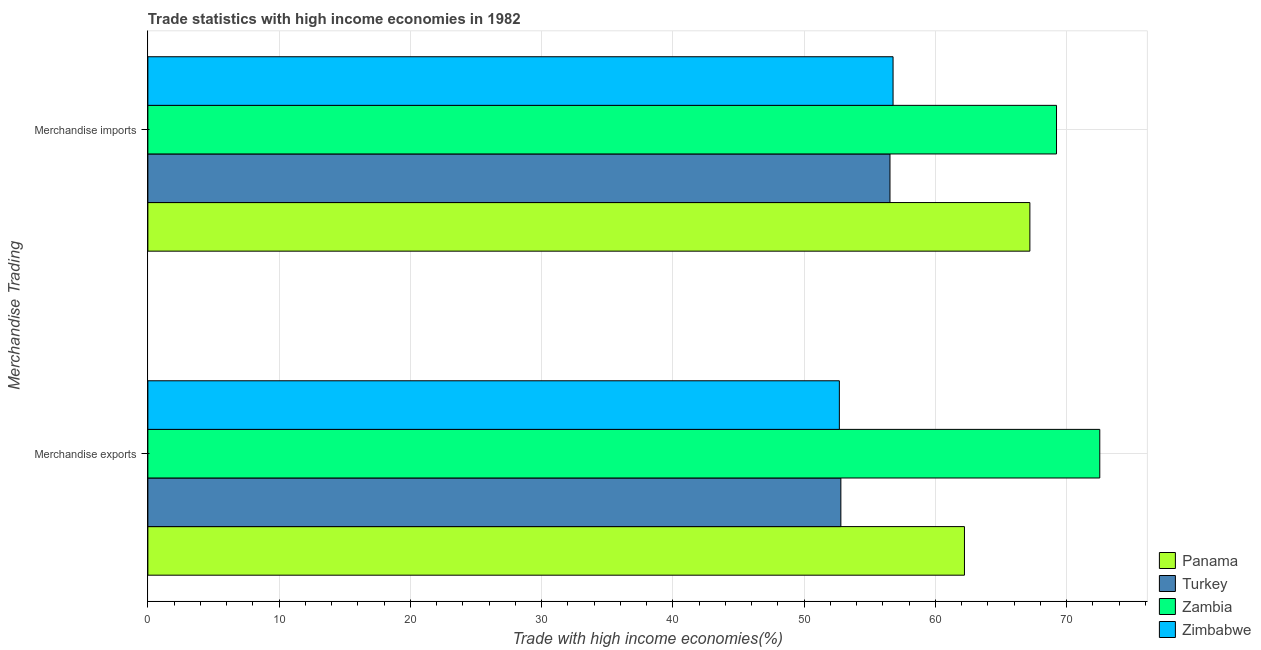Are the number of bars on each tick of the Y-axis equal?
Ensure brevity in your answer.  Yes. What is the merchandise imports in Panama?
Your answer should be very brief. 67.2. Across all countries, what is the maximum merchandise exports?
Offer a terse response. 72.52. Across all countries, what is the minimum merchandise imports?
Provide a short and direct response. 56.54. In which country was the merchandise imports maximum?
Your answer should be compact. Zambia. In which country was the merchandise exports minimum?
Your answer should be very brief. Zimbabwe. What is the total merchandise imports in the graph?
Your answer should be very brief. 249.73. What is the difference between the merchandise imports in Panama and that in Turkey?
Ensure brevity in your answer.  10.66. What is the difference between the merchandise exports in Zimbabwe and the merchandise imports in Zambia?
Keep it short and to the point. -16.54. What is the average merchandise exports per country?
Ensure brevity in your answer.  60.05. What is the difference between the merchandise exports and merchandise imports in Zimbabwe?
Your answer should be compact. -4.09. What is the ratio of the merchandise exports in Zambia to that in Panama?
Your answer should be compact. 1.17. In how many countries, is the merchandise exports greater than the average merchandise exports taken over all countries?
Keep it short and to the point. 2. What does the 1st bar from the top in Merchandise imports represents?
Your answer should be very brief. Zimbabwe. What does the 1st bar from the bottom in Merchandise exports represents?
Provide a short and direct response. Panama. How many bars are there?
Give a very brief answer. 8. Are all the bars in the graph horizontal?
Offer a very short reply. Yes. How many countries are there in the graph?
Offer a very short reply. 4. What is the difference between two consecutive major ticks on the X-axis?
Give a very brief answer. 10. How many legend labels are there?
Offer a very short reply. 4. How are the legend labels stacked?
Provide a short and direct response. Vertical. What is the title of the graph?
Offer a very short reply. Trade statistics with high income economies in 1982. Does "Saudi Arabia" appear as one of the legend labels in the graph?
Offer a very short reply. No. What is the label or title of the X-axis?
Provide a succinct answer. Trade with high income economies(%). What is the label or title of the Y-axis?
Offer a very short reply. Merchandise Trading. What is the Trade with high income economies(%) of Panama in Merchandise exports?
Ensure brevity in your answer.  62.21. What is the Trade with high income economies(%) in Turkey in Merchandise exports?
Ensure brevity in your answer.  52.8. What is the Trade with high income economies(%) of Zambia in Merchandise exports?
Offer a very short reply. 72.52. What is the Trade with high income economies(%) in Zimbabwe in Merchandise exports?
Provide a short and direct response. 52.68. What is the Trade with high income economies(%) in Panama in Merchandise imports?
Give a very brief answer. 67.2. What is the Trade with high income economies(%) of Turkey in Merchandise imports?
Make the answer very short. 56.54. What is the Trade with high income economies(%) of Zambia in Merchandise imports?
Your response must be concise. 69.23. What is the Trade with high income economies(%) in Zimbabwe in Merchandise imports?
Your answer should be compact. 56.77. Across all Merchandise Trading, what is the maximum Trade with high income economies(%) in Panama?
Provide a short and direct response. 67.2. Across all Merchandise Trading, what is the maximum Trade with high income economies(%) in Turkey?
Provide a succinct answer. 56.54. Across all Merchandise Trading, what is the maximum Trade with high income economies(%) of Zambia?
Offer a terse response. 72.52. Across all Merchandise Trading, what is the maximum Trade with high income economies(%) in Zimbabwe?
Offer a very short reply. 56.77. Across all Merchandise Trading, what is the minimum Trade with high income economies(%) of Panama?
Your answer should be very brief. 62.21. Across all Merchandise Trading, what is the minimum Trade with high income economies(%) of Turkey?
Offer a very short reply. 52.8. Across all Merchandise Trading, what is the minimum Trade with high income economies(%) of Zambia?
Your answer should be very brief. 69.23. Across all Merchandise Trading, what is the minimum Trade with high income economies(%) of Zimbabwe?
Keep it short and to the point. 52.68. What is the total Trade with high income economies(%) in Panama in the graph?
Keep it short and to the point. 129.41. What is the total Trade with high income economies(%) in Turkey in the graph?
Your response must be concise. 109.33. What is the total Trade with high income economies(%) of Zambia in the graph?
Ensure brevity in your answer.  141.75. What is the total Trade with high income economies(%) of Zimbabwe in the graph?
Your answer should be very brief. 109.45. What is the difference between the Trade with high income economies(%) of Panama in Merchandise exports and that in Merchandise imports?
Provide a short and direct response. -4.98. What is the difference between the Trade with high income economies(%) in Turkey in Merchandise exports and that in Merchandise imports?
Keep it short and to the point. -3.74. What is the difference between the Trade with high income economies(%) of Zambia in Merchandise exports and that in Merchandise imports?
Offer a terse response. 3.3. What is the difference between the Trade with high income economies(%) in Zimbabwe in Merchandise exports and that in Merchandise imports?
Your answer should be very brief. -4.09. What is the difference between the Trade with high income economies(%) of Panama in Merchandise exports and the Trade with high income economies(%) of Turkey in Merchandise imports?
Make the answer very short. 5.67. What is the difference between the Trade with high income economies(%) of Panama in Merchandise exports and the Trade with high income economies(%) of Zambia in Merchandise imports?
Provide a succinct answer. -7.01. What is the difference between the Trade with high income economies(%) in Panama in Merchandise exports and the Trade with high income economies(%) in Zimbabwe in Merchandise imports?
Ensure brevity in your answer.  5.44. What is the difference between the Trade with high income economies(%) in Turkey in Merchandise exports and the Trade with high income economies(%) in Zambia in Merchandise imports?
Your response must be concise. -16.43. What is the difference between the Trade with high income economies(%) of Turkey in Merchandise exports and the Trade with high income economies(%) of Zimbabwe in Merchandise imports?
Give a very brief answer. -3.98. What is the difference between the Trade with high income economies(%) in Zambia in Merchandise exports and the Trade with high income economies(%) in Zimbabwe in Merchandise imports?
Ensure brevity in your answer.  15.75. What is the average Trade with high income economies(%) of Panama per Merchandise Trading?
Keep it short and to the point. 64.7. What is the average Trade with high income economies(%) of Turkey per Merchandise Trading?
Give a very brief answer. 54.67. What is the average Trade with high income economies(%) of Zambia per Merchandise Trading?
Provide a succinct answer. 70.87. What is the average Trade with high income economies(%) of Zimbabwe per Merchandise Trading?
Your answer should be very brief. 54.73. What is the difference between the Trade with high income economies(%) in Panama and Trade with high income economies(%) in Turkey in Merchandise exports?
Your answer should be very brief. 9.42. What is the difference between the Trade with high income economies(%) in Panama and Trade with high income economies(%) in Zambia in Merchandise exports?
Provide a short and direct response. -10.31. What is the difference between the Trade with high income economies(%) in Panama and Trade with high income economies(%) in Zimbabwe in Merchandise exports?
Offer a very short reply. 9.53. What is the difference between the Trade with high income economies(%) in Turkey and Trade with high income economies(%) in Zambia in Merchandise exports?
Your answer should be very brief. -19.73. What is the difference between the Trade with high income economies(%) of Turkey and Trade with high income economies(%) of Zimbabwe in Merchandise exports?
Keep it short and to the point. 0.11. What is the difference between the Trade with high income economies(%) in Zambia and Trade with high income economies(%) in Zimbabwe in Merchandise exports?
Offer a terse response. 19.84. What is the difference between the Trade with high income economies(%) of Panama and Trade with high income economies(%) of Turkey in Merchandise imports?
Give a very brief answer. 10.66. What is the difference between the Trade with high income economies(%) in Panama and Trade with high income economies(%) in Zambia in Merchandise imports?
Ensure brevity in your answer.  -2.03. What is the difference between the Trade with high income economies(%) of Panama and Trade with high income economies(%) of Zimbabwe in Merchandise imports?
Ensure brevity in your answer.  10.42. What is the difference between the Trade with high income economies(%) of Turkey and Trade with high income economies(%) of Zambia in Merchandise imports?
Your response must be concise. -12.69. What is the difference between the Trade with high income economies(%) of Turkey and Trade with high income economies(%) of Zimbabwe in Merchandise imports?
Offer a terse response. -0.23. What is the difference between the Trade with high income economies(%) of Zambia and Trade with high income economies(%) of Zimbabwe in Merchandise imports?
Give a very brief answer. 12.45. What is the ratio of the Trade with high income economies(%) of Panama in Merchandise exports to that in Merchandise imports?
Your answer should be compact. 0.93. What is the ratio of the Trade with high income economies(%) in Turkey in Merchandise exports to that in Merchandise imports?
Your response must be concise. 0.93. What is the ratio of the Trade with high income economies(%) in Zambia in Merchandise exports to that in Merchandise imports?
Keep it short and to the point. 1.05. What is the ratio of the Trade with high income economies(%) in Zimbabwe in Merchandise exports to that in Merchandise imports?
Offer a terse response. 0.93. What is the difference between the highest and the second highest Trade with high income economies(%) in Panama?
Make the answer very short. 4.98. What is the difference between the highest and the second highest Trade with high income economies(%) of Turkey?
Provide a succinct answer. 3.74. What is the difference between the highest and the second highest Trade with high income economies(%) of Zambia?
Give a very brief answer. 3.3. What is the difference between the highest and the second highest Trade with high income economies(%) in Zimbabwe?
Offer a very short reply. 4.09. What is the difference between the highest and the lowest Trade with high income economies(%) in Panama?
Provide a succinct answer. 4.98. What is the difference between the highest and the lowest Trade with high income economies(%) of Turkey?
Provide a succinct answer. 3.74. What is the difference between the highest and the lowest Trade with high income economies(%) of Zambia?
Make the answer very short. 3.3. What is the difference between the highest and the lowest Trade with high income economies(%) of Zimbabwe?
Offer a terse response. 4.09. 